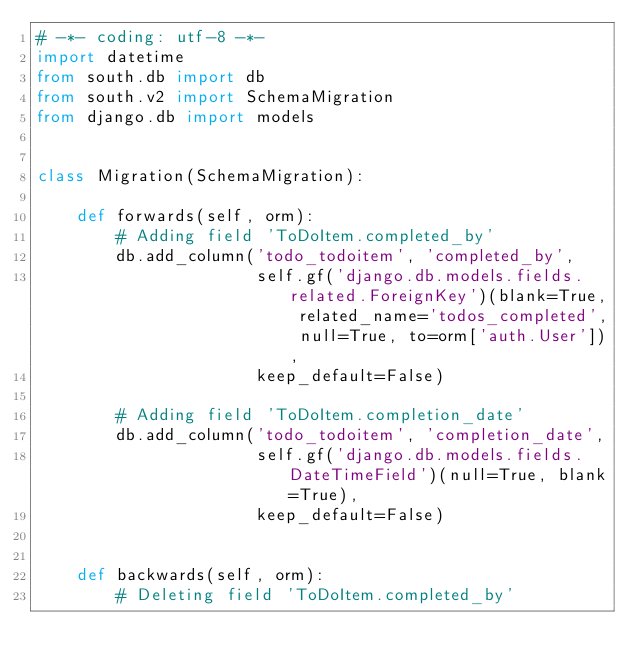Convert code to text. <code><loc_0><loc_0><loc_500><loc_500><_Python_># -*- coding: utf-8 -*-
import datetime
from south.db import db
from south.v2 import SchemaMigration
from django.db import models


class Migration(SchemaMigration):

    def forwards(self, orm):
        # Adding field 'ToDoItem.completed_by'
        db.add_column('todo_todoitem', 'completed_by',
                      self.gf('django.db.models.fields.related.ForeignKey')(blank=True, related_name='todos_completed', null=True, to=orm['auth.User']),
                      keep_default=False)

        # Adding field 'ToDoItem.completion_date'
        db.add_column('todo_todoitem', 'completion_date',
                      self.gf('django.db.models.fields.DateTimeField')(null=True, blank=True),
                      keep_default=False)


    def backwards(self, orm):
        # Deleting field 'ToDoItem.completed_by'</code> 